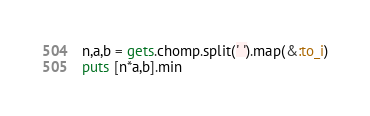<code> <loc_0><loc_0><loc_500><loc_500><_Ruby_>n,a,b = gets.chomp.split(' ').map(&:to_i)
puts [n*a,b].min</code> 